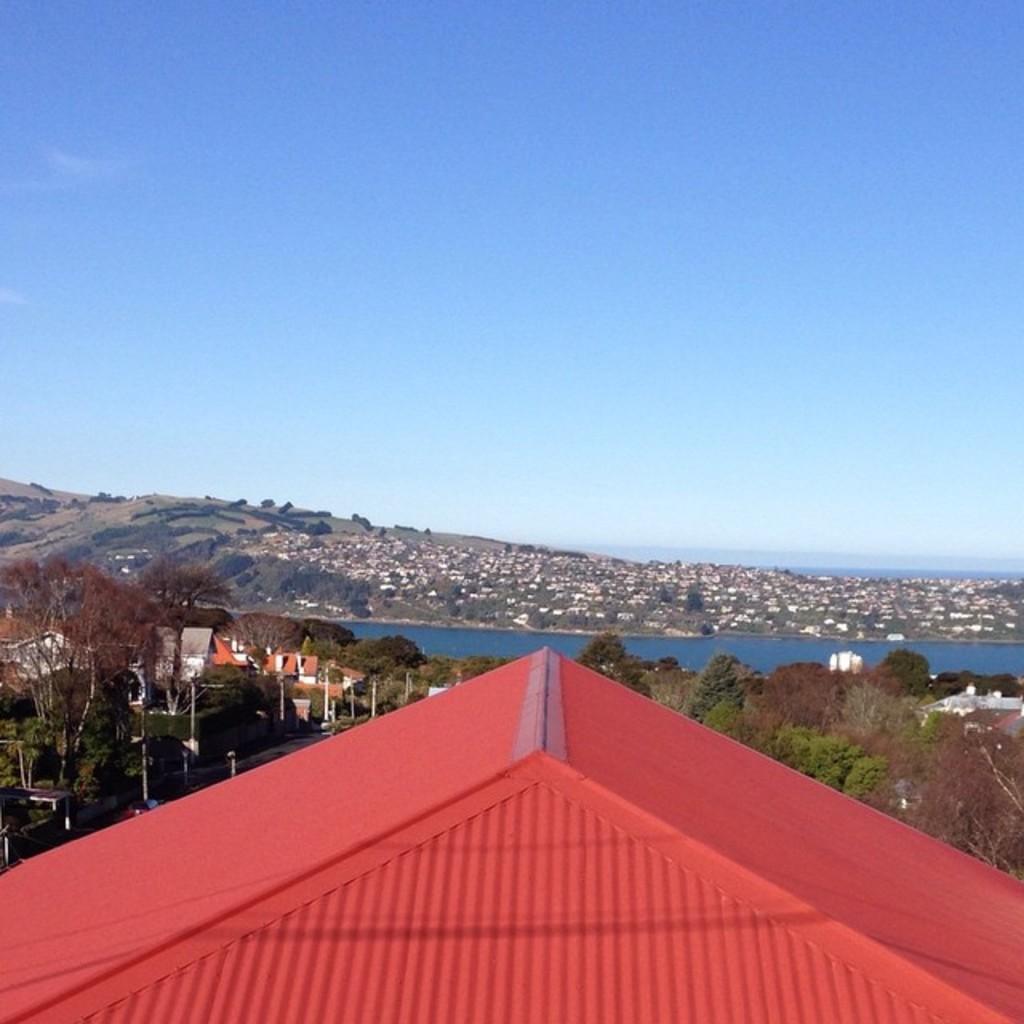How would you summarize this image in a sentence or two? In this image, I can see trees, buildings, a hill and water. At the bottom of the image, I can see the roof. In the background, there is the sky. 